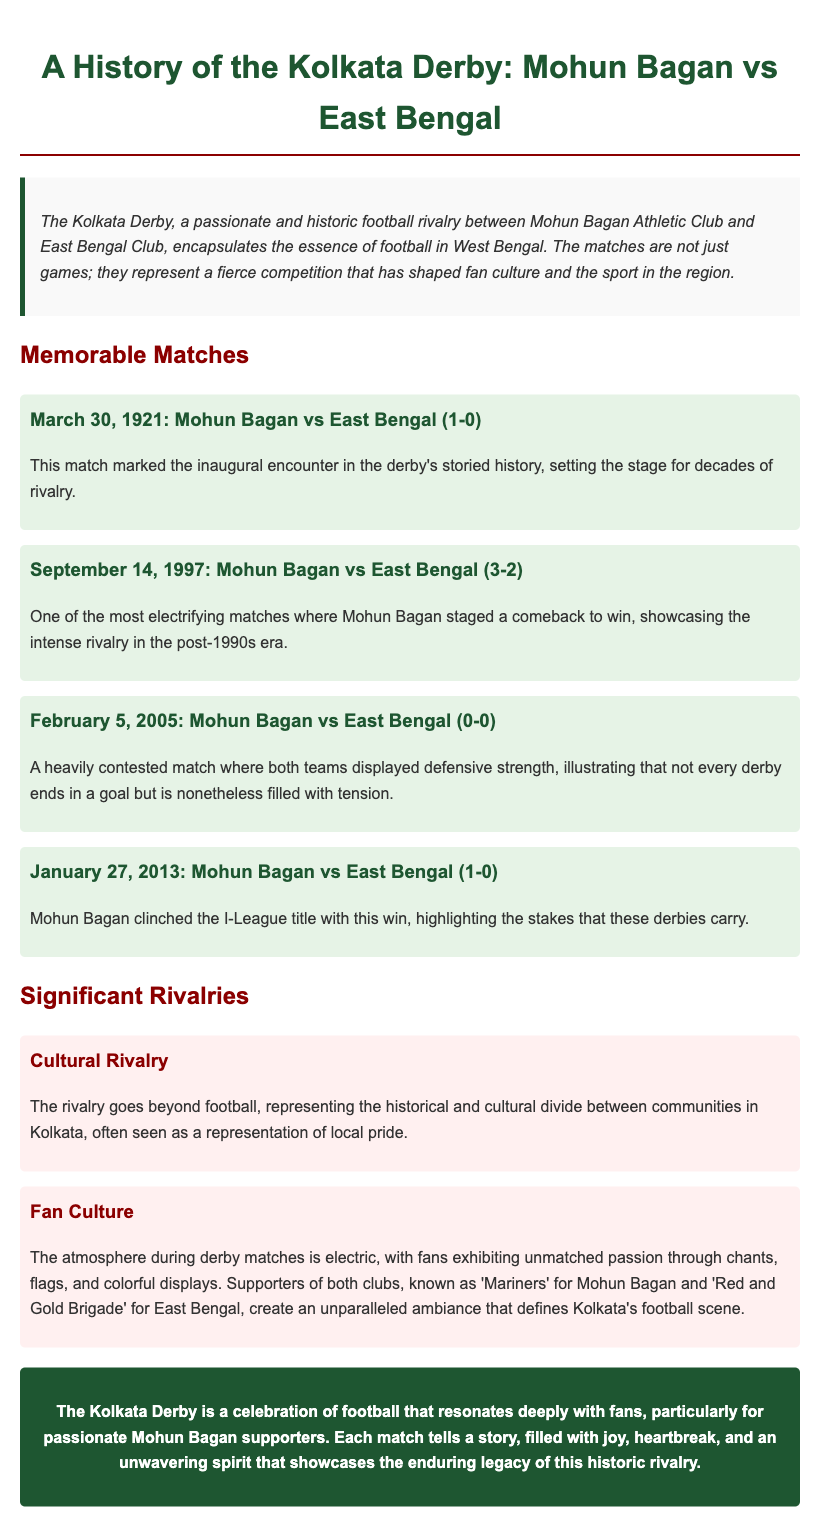What is the date of the inaugural Kolkata Derby match? The inaugural match was played on March 30, 1921, marking the beginning of the derby's history.
Answer: March 30, 1921 How many goals did Mohun Bagan score in the match on September 14, 1997? Mohun Bagan scored 3 goals against East Bengal in this electrifying match.
Answer: 3 What was the outcome of the match on February 5, 2005? This heavily contested match ended in a 0-0 draw, showcasing strong defensive play.
Answer: 0-0 In which year did Mohun Bagan clinch the I-League title with a victory over East Bengal? Mohun Bagan won the I-League title on January 27, 2013, with a 1-0 victory.
Answer: 2013 What is the nickname of Mohun Bagan supporters? Mohun Bagan fans are referred to as 'Mariners'.
Answer: Mariners What does the cultural rivalry in the Kolkata Derby represent? The cultural rivalry embodies a historical and cultural divide between communities in Kolkata.
Answer: Historical and cultural divide Describe the atmosphere during derby matches. The atmosphere is electric, filled with passion, chants, flags, and colorful displays by fans.
Answer: Electric What are the supporters of East Bengal known as? The supporters of East Bengal are known as the 'Red and Gold Brigade'.
Answer: Red and Gold Brigade What type of match was highlighted by the January 27, 2013 encounter? The match highlighted the high stakes of derby matches, especially as it clinched the I-League title.
Answer: High stakes 